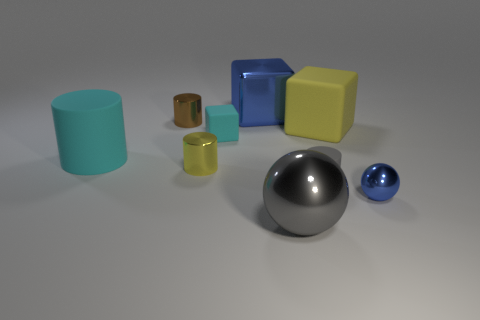Subtract all red cylinders. Subtract all cyan spheres. How many cylinders are left? 4 Subtract all cubes. How many objects are left? 6 Add 6 yellow shiny cubes. How many yellow shiny cubes exist? 6 Subtract 0 blue cylinders. How many objects are left? 9 Subtract all rubber things. Subtract all blue metallic things. How many objects are left? 3 Add 4 tiny blue spheres. How many tiny blue spheres are left? 5 